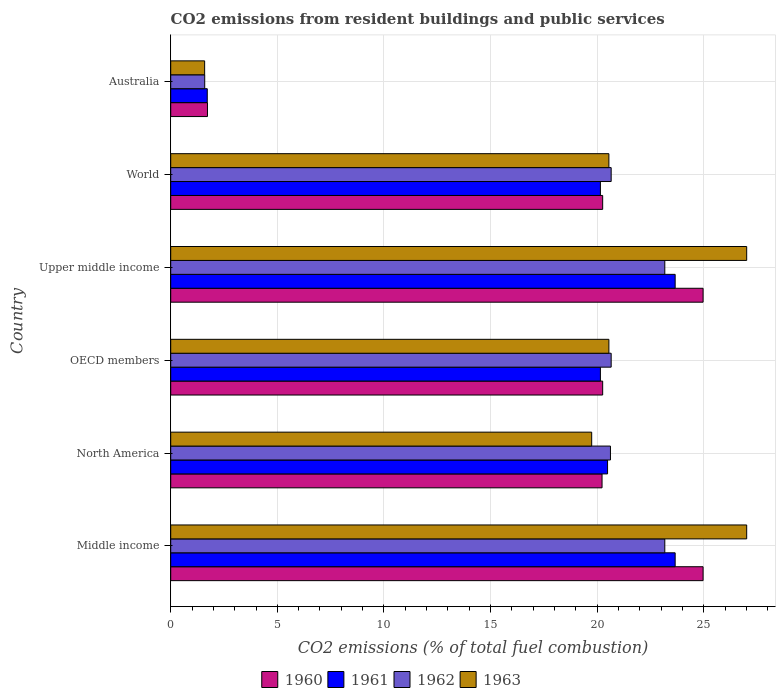How many different coloured bars are there?
Your response must be concise. 4. How many groups of bars are there?
Provide a succinct answer. 6. How many bars are there on the 6th tick from the top?
Your answer should be very brief. 4. How many bars are there on the 4th tick from the bottom?
Make the answer very short. 4. What is the label of the 6th group of bars from the top?
Ensure brevity in your answer.  Middle income. What is the total CO2 emitted in 1961 in Australia?
Your response must be concise. 1.71. Across all countries, what is the maximum total CO2 emitted in 1961?
Give a very brief answer. 23.66. Across all countries, what is the minimum total CO2 emitted in 1963?
Your response must be concise. 1.59. In which country was the total CO2 emitted in 1961 maximum?
Ensure brevity in your answer.  Middle income. In which country was the total CO2 emitted in 1963 minimum?
Offer a very short reply. Australia. What is the total total CO2 emitted in 1961 in the graph?
Provide a succinct answer. 109.83. What is the difference between the total CO2 emitted in 1963 in Australia and that in OECD members?
Ensure brevity in your answer.  -18.96. What is the difference between the total CO2 emitted in 1960 in North America and the total CO2 emitted in 1961 in World?
Keep it short and to the point. 0.08. What is the average total CO2 emitted in 1960 per country?
Make the answer very short. 18.74. What is the difference between the total CO2 emitted in 1963 and total CO2 emitted in 1961 in Middle income?
Provide a short and direct response. 3.36. What is the ratio of the total CO2 emitted in 1962 in Upper middle income to that in World?
Keep it short and to the point. 1.12. What is the difference between the highest and the second highest total CO2 emitted in 1962?
Offer a terse response. 0. What is the difference between the highest and the lowest total CO2 emitted in 1963?
Make the answer very short. 25.42. In how many countries, is the total CO2 emitted in 1961 greater than the average total CO2 emitted in 1961 taken over all countries?
Give a very brief answer. 5. Is it the case that in every country, the sum of the total CO2 emitted in 1962 and total CO2 emitted in 1961 is greater than the sum of total CO2 emitted in 1960 and total CO2 emitted in 1963?
Provide a succinct answer. No. What does the 1st bar from the top in Middle income represents?
Ensure brevity in your answer.  1963. What does the 2nd bar from the bottom in OECD members represents?
Your answer should be very brief. 1961. Are all the bars in the graph horizontal?
Your answer should be very brief. Yes. Where does the legend appear in the graph?
Give a very brief answer. Bottom center. How are the legend labels stacked?
Your answer should be very brief. Horizontal. What is the title of the graph?
Offer a terse response. CO2 emissions from resident buildings and public services. What is the label or title of the X-axis?
Keep it short and to the point. CO2 emissions (% of total fuel combustion). What is the CO2 emissions (% of total fuel combustion) in 1960 in Middle income?
Your answer should be very brief. 24.97. What is the CO2 emissions (% of total fuel combustion) of 1961 in Middle income?
Your response must be concise. 23.66. What is the CO2 emissions (% of total fuel combustion) in 1962 in Middle income?
Offer a terse response. 23.17. What is the CO2 emissions (% of total fuel combustion) of 1963 in Middle income?
Your answer should be very brief. 27.01. What is the CO2 emissions (% of total fuel combustion) in 1960 in North America?
Give a very brief answer. 20.23. What is the CO2 emissions (% of total fuel combustion) of 1961 in North America?
Your answer should be very brief. 20.49. What is the CO2 emissions (% of total fuel combustion) of 1962 in North America?
Offer a very short reply. 20.62. What is the CO2 emissions (% of total fuel combustion) of 1963 in North America?
Your response must be concise. 19.74. What is the CO2 emissions (% of total fuel combustion) in 1960 in OECD members?
Ensure brevity in your answer.  20.26. What is the CO2 emissions (% of total fuel combustion) in 1961 in OECD members?
Provide a succinct answer. 20.15. What is the CO2 emissions (% of total fuel combustion) of 1962 in OECD members?
Offer a very short reply. 20.66. What is the CO2 emissions (% of total fuel combustion) in 1963 in OECD members?
Make the answer very short. 20.55. What is the CO2 emissions (% of total fuel combustion) of 1960 in Upper middle income?
Provide a short and direct response. 24.97. What is the CO2 emissions (% of total fuel combustion) of 1961 in Upper middle income?
Ensure brevity in your answer.  23.66. What is the CO2 emissions (% of total fuel combustion) of 1962 in Upper middle income?
Offer a very short reply. 23.17. What is the CO2 emissions (% of total fuel combustion) of 1963 in Upper middle income?
Your response must be concise. 27.01. What is the CO2 emissions (% of total fuel combustion) in 1960 in World?
Give a very brief answer. 20.26. What is the CO2 emissions (% of total fuel combustion) of 1961 in World?
Your response must be concise. 20.15. What is the CO2 emissions (% of total fuel combustion) of 1962 in World?
Your answer should be very brief. 20.66. What is the CO2 emissions (% of total fuel combustion) of 1963 in World?
Provide a succinct answer. 20.55. What is the CO2 emissions (% of total fuel combustion) in 1960 in Australia?
Give a very brief answer. 1.72. What is the CO2 emissions (% of total fuel combustion) in 1961 in Australia?
Provide a short and direct response. 1.71. What is the CO2 emissions (% of total fuel combustion) in 1962 in Australia?
Keep it short and to the point. 1.59. What is the CO2 emissions (% of total fuel combustion) in 1963 in Australia?
Make the answer very short. 1.59. Across all countries, what is the maximum CO2 emissions (% of total fuel combustion) of 1960?
Provide a short and direct response. 24.97. Across all countries, what is the maximum CO2 emissions (% of total fuel combustion) in 1961?
Provide a succinct answer. 23.66. Across all countries, what is the maximum CO2 emissions (% of total fuel combustion) of 1962?
Your answer should be compact. 23.17. Across all countries, what is the maximum CO2 emissions (% of total fuel combustion) in 1963?
Provide a short and direct response. 27.01. Across all countries, what is the minimum CO2 emissions (% of total fuel combustion) in 1960?
Provide a short and direct response. 1.72. Across all countries, what is the minimum CO2 emissions (% of total fuel combustion) in 1961?
Keep it short and to the point. 1.71. Across all countries, what is the minimum CO2 emissions (% of total fuel combustion) of 1962?
Give a very brief answer. 1.59. Across all countries, what is the minimum CO2 emissions (% of total fuel combustion) of 1963?
Your answer should be compact. 1.59. What is the total CO2 emissions (% of total fuel combustion) in 1960 in the graph?
Give a very brief answer. 112.41. What is the total CO2 emissions (% of total fuel combustion) of 1961 in the graph?
Ensure brevity in your answer.  109.83. What is the total CO2 emissions (% of total fuel combustion) in 1962 in the graph?
Offer a very short reply. 109.88. What is the total CO2 emissions (% of total fuel combustion) of 1963 in the graph?
Give a very brief answer. 116.47. What is the difference between the CO2 emissions (% of total fuel combustion) of 1960 in Middle income and that in North America?
Your answer should be compact. 4.74. What is the difference between the CO2 emissions (% of total fuel combustion) in 1961 in Middle income and that in North America?
Your response must be concise. 3.17. What is the difference between the CO2 emissions (% of total fuel combustion) of 1962 in Middle income and that in North America?
Offer a very short reply. 2.55. What is the difference between the CO2 emissions (% of total fuel combustion) of 1963 in Middle income and that in North America?
Offer a terse response. 7.27. What is the difference between the CO2 emissions (% of total fuel combustion) in 1960 in Middle income and that in OECD members?
Make the answer very short. 4.71. What is the difference between the CO2 emissions (% of total fuel combustion) of 1961 in Middle income and that in OECD members?
Ensure brevity in your answer.  3.51. What is the difference between the CO2 emissions (% of total fuel combustion) of 1962 in Middle income and that in OECD members?
Ensure brevity in your answer.  2.52. What is the difference between the CO2 emissions (% of total fuel combustion) of 1963 in Middle income and that in OECD members?
Provide a succinct answer. 6.46. What is the difference between the CO2 emissions (% of total fuel combustion) in 1962 in Middle income and that in Upper middle income?
Provide a short and direct response. 0. What is the difference between the CO2 emissions (% of total fuel combustion) in 1960 in Middle income and that in World?
Keep it short and to the point. 4.71. What is the difference between the CO2 emissions (% of total fuel combustion) of 1961 in Middle income and that in World?
Ensure brevity in your answer.  3.51. What is the difference between the CO2 emissions (% of total fuel combustion) in 1962 in Middle income and that in World?
Offer a terse response. 2.52. What is the difference between the CO2 emissions (% of total fuel combustion) in 1963 in Middle income and that in World?
Provide a short and direct response. 6.46. What is the difference between the CO2 emissions (% of total fuel combustion) in 1960 in Middle income and that in Australia?
Offer a very short reply. 23.25. What is the difference between the CO2 emissions (% of total fuel combustion) in 1961 in Middle income and that in Australia?
Provide a succinct answer. 21.95. What is the difference between the CO2 emissions (% of total fuel combustion) in 1962 in Middle income and that in Australia?
Provide a short and direct response. 21.58. What is the difference between the CO2 emissions (% of total fuel combustion) of 1963 in Middle income and that in Australia?
Keep it short and to the point. 25.42. What is the difference between the CO2 emissions (% of total fuel combustion) in 1960 in North America and that in OECD members?
Offer a very short reply. -0.03. What is the difference between the CO2 emissions (% of total fuel combustion) of 1961 in North America and that in OECD members?
Provide a succinct answer. 0.34. What is the difference between the CO2 emissions (% of total fuel combustion) in 1962 in North America and that in OECD members?
Offer a terse response. -0.03. What is the difference between the CO2 emissions (% of total fuel combustion) of 1963 in North America and that in OECD members?
Ensure brevity in your answer.  -0.81. What is the difference between the CO2 emissions (% of total fuel combustion) in 1960 in North America and that in Upper middle income?
Offer a terse response. -4.74. What is the difference between the CO2 emissions (% of total fuel combustion) in 1961 in North America and that in Upper middle income?
Provide a short and direct response. -3.17. What is the difference between the CO2 emissions (% of total fuel combustion) in 1962 in North America and that in Upper middle income?
Ensure brevity in your answer.  -2.55. What is the difference between the CO2 emissions (% of total fuel combustion) in 1963 in North America and that in Upper middle income?
Provide a short and direct response. -7.27. What is the difference between the CO2 emissions (% of total fuel combustion) of 1960 in North America and that in World?
Ensure brevity in your answer.  -0.03. What is the difference between the CO2 emissions (% of total fuel combustion) of 1961 in North America and that in World?
Your answer should be very brief. 0.34. What is the difference between the CO2 emissions (% of total fuel combustion) in 1962 in North America and that in World?
Offer a very short reply. -0.03. What is the difference between the CO2 emissions (% of total fuel combustion) of 1963 in North America and that in World?
Keep it short and to the point. -0.81. What is the difference between the CO2 emissions (% of total fuel combustion) of 1960 in North America and that in Australia?
Give a very brief answer. 18.51. What is the difference between the CO2 emissions (% of total fuel combustion) of 1961 in North America and that in Australia?
Make the answer very short. 18.77. What is the difference between the CO2 emissions (% of total fuel combustion) in 1962 in North America and that in Australia?
Your response must be concise. 19.03. What is the difference between the CO2 emissions (% of total fuel combustion) in 1963 in North America and that in Australia?
Your answer should be very brief. 18.15. What is the difference between the CO2 emissions (% of total fuel combustion) of 1960 in OECD members and that in Upper middle income?
Provide a short and direct response. -4.71. What is the difference between the CO2 emissions (% of total fuel combustion) in 1961 in OECD members and that in Upper middle income?
Ensure brevity in your answer.  -3.51. What is the difference between the CO2 emissions (% of total fuel combustion) of 1962 in OECD members and that in Upper middle income?
Your answer should be very brief. -2.52. What is the difference between the CO2 emissions (% of total fuel combustion) of 1963 in OECD members and that in Upper middle income?
Your response must be concise. -6.46. What is the difference between the CO2 emissions (% of total fuel combustion) of 1961 in OECD members and that in World?
Provide a short and direct response. 0. What is the difference between the CO2 emissions (% of total fuel combustion) in 1962 in OECD members and that in World?
Your answer should be compact. 0. What is the difference between the CO2 emissions (% of total fuel combustion) of 1963 in OECD members and that in World?
Provide a succinct answer. 0. What is the difference between the CO2 emissions (% of total fuel combustion) of 1960 in OECD members and that in Australia?
Your answer should be compact. 18.54. What is the difference between the CO2 emissions (% of total fuel combustion) of 1961 in OECD members and that in Australia?
Ensure brevity in your answer.  18.44. What is the difference between the CO2 emissions (% of total fuel combustion) of 1962 in OECD members and that in Australia?
Provide a succinct answer. 19.06. What is the difference between the CO2 emissions (% of total fuel combustion) of 1963 in OECD members and that in Australia?
Your response must be concise. 18.96. What is the difference between the CO2 emissions (% of total fuel combustion) of 1960 in Upper middle income and that in World?
Ensure brevity in your answer.  4.71. What is the difference between the CO2 emissions (% of total fuel combustion) in 1961 in Upper middle income and that in World?
Give a very brief answer. 3.51. What is the difference between the CO2 emissions (% of total fuel combustion) of 1962 in Upper middle income and that in World?
Your answer should be very brief. 2.52. What is the difference between the CO2 emissions (% of total fuel combustion) in 1963 in Upper middle income and that in World?
Give a very brief answer. 6.46. What is the difference between the CO2 emissions (% of total fuel combustion) of 1960 in Upper middle income and that in Australia?
Keep it short and to the point. 23.25. What is the difference between the CO2 emissions (% of total fuel combustion) of 1961 in Upper middle income and that in Australia?
Offer a terse response. 21.95. What is the difference between the CO2 emissions (% of total fuel combustion) in 1962 in Upper middle income and that in Australia?
Provide a short and direct response. 21.58. What is the difference between the CO2 emissions (% of total fuel combustion) in 1963 in Upper middle income and that in Australia?
Your response must be concise. 25.42. What is the difference between the CO2 emissions (% of total fuel combustion) of 1960 in World and that in Australia?
Offer a very short reply. 18.54. What is the difference between the CO2 emissions (% of total fuel combustion) in 1961 in World and that in Australia?
Your answer should be compact. 18.44. What is the difference between the CO2 emissions (% of total fuel combustion) in 1962 in World and that in Australia?
Your response must be concise. 19.06. What is the difference between the CO2 emissions (% of total fuel combustion) of 1963 in World and that in Australia?
Your answer should be compact. 18.96. What is the difference between the CO2 emissions (% of total fuel combustion) of 1960 in Middle income and the CO2 emissions (% of total fuel combustion) of 1961 in North America?
Provide a short and direct response. 4.48. What is the difference between the CO2 emissions (% of total fuel combustion) of 1960 in Middle income and the CO2 emissions (% of total fuel combustion) of 1962 in North America?
Keep it short and to the point. 4.35. What is the difference between the CO2 emissions (% of total fuel combustion) of 1960 in Middle income and the CO2 emissions (% of total fuel combustion) of 1963 in North America?
Offer a terse response. 5.22. What is the difference between the CO2 emissions (% of total fuel combustion) in 1961 in Middle income and the CO2 emissions (% of total fuel combustion) in 1962 in North America?
Your answer should be very brief. 3.04. What is the difference between the CO2 emissions (% of total fuel combustion) in 1961 in Middle income and the CO2 emissions (% of total fuel combustion) in 1963 in North America?
Ensure brevity in your answer.  3.92. What is the difference between the CO2 emissions (% of total fuel combustion) in 1962 in Middle income and the CO2 emissions (% of total fuel combustion) in 1963 in North America?
Provide a succinct answer. 3.43. What is the difference between the CO2 emissions (% of total fuel combustion) of 1960 in Middle income and the CO2 emissions (% of total fuel combustion) of 1961 in OECD members?
Keep it short and to the point. 4.82. What is the difference between the CO2 emissions (% of total fuel combustion) of 1960 in Middle income and the CO2 emissions (% of total fuel combustion) of 1962 in OECD members?
Your response must be concise. 4.31. What is the difference between the CO2 emissions (% of total fuel combustion) of 1960 in Middle income and the CO2 emissions (% of total fuel combustion) of 1963 in OECD members?
Provide a short and direct response. 4.42. What is the difference between the CO2 emissions (% of total fuel combustion) in 1961 in Middle income and the CO2 emissions (% of total fuel combustion) in 1962 in OECD members?
Keep it short and to the point. 3. What is the difference between the CO2 emissions (% of total fuel combustion) in 1961 in Middle income and the CO2 emissions (% of total fuel combustion) in 1963 in OECD members?
Your answer should be very brief. 3.11. What is the difference between the CO2 emissions (% of total fuel combustion) in 1962 in Middle income and the CO2 emissions (% of total fuel combustion) in 1963 in OECD members?
Make the answer very short. 2.62. What is the difference between the CO2 emissions (% of total fuel combustion) in 1960 in Middle income and the CO2 emissions (% of total fuel combustion) in 1961 in Upper middle income?
Your response must be concise. 1.31. What is the difference between the CO2 emissions (% of total fuel combustion) in 1960 in Middle income and the CO2 emissions (% of total fuel combustion) in 1962 in Upper middle income?
Provide a short and direct response. 1.8. What is the difference between the CO2 emissions (% of total fuel combustion) in 1960 in Middle income and the CO2 emissions (% of total fuel combustion) in 1963 in Upper middle income?
Make the answer very short. -2.05. What is the difference between the CO2 emissions (% of total fuel combustion) in 1961 in Middle income and the CO2 emissions (% of total fuel combustion) in 1962 in Upper middle income?
Your response must be concise. 0.49. What is the difference between the CO2 emissions (% of total fuel combustion) of 1961 in Middle income and the CO2 emissions (% of total fuel combustion) of 1963 in Upper middle income?
Provide a short and direct response. -3.35. What is the difference between the CO2 emissions (% of total fuel combustion) in 1962 in Middle income and the CO2 emissions (% of total fuel combustion) in 1963 in Upper middle income?
Give a very brief answer. -3.84. What is the difference between the CO2 emissions (% of total fuel combustion) in 1960 in Middle income and the CO2 emissions (% of total fuel combustion) in 1961 in World?
Give a very brief answer. 4.82. What is the difference between the CO2 emissions (% of total fuel combustion) of 1960 in Middle income and the CO2 emissions (% of total fuel combustion) of 1962 in World?
Make the answer very short. 4.31. What is the difference between the CO2 emissions (% of total fuel combustion) of 1960 in Middle income and the CO2 emissions (% of total fuel combustion) of 1963 in World?
Provide a short and direct response. 4.42. What is the difference between the CO2 emissions (% of total fuel combustion) of 1961 in Middle income and the CO2 emissions (% of total fuel combustion) of 1962 in World?
Offer a terse response. 3. What is the difference between the CO2 emissions (% of total fuel combustion) of 1961 in Middle income and the CO2 emissions (% of total fuel combustion) of 1963 in World?
Offer a very short reply. 3.11. What is the difference between the CO2 emissions (% of total fuel combustion) in 1962 in Middle income and the CO2 emissions (% of total fuel combustion) in 1963 in World?
Provide a succinct answer. 2.62. What is the difference between the CO2 emissions (% of total fuel combustion) of 1960 in Middle income and the CO2 emissions (% of total fuel combustion) of 1961 in Australia?
Make the answer very short. 23.26. What is the difference between the CO2 emissions (% of total fuel combustion) of 1960 in Middle income and the CO2 emissions (% of total fuel combustion) of 1962 in Australia?
Keep it short and to the point. 23.38. What is the difference between the CO2 emissions (% of total fuel combustion) of 1960 in Middle income and the CO2 emissions (% of total fuel combustion) of 1963 in Australia?
Your answer should be compact. 23.38. What is the difference between the CO2 emissions (% of total fuel combustion) in 1961 in Middle income and the CO2 emissions (% of total fuel combustion) in 1962 in Australia?
Ensure brevity in your answer.  22.07. What is the difference between the CO2 emissions (% of total fuel combustion) of 1961 in Middle income and the CO2 emissions (% of total fuel combustion) of 1963 in Australia?
Offer a very short reply. 22.07. What is the difference between the CO2 emissions (% of total fuel combustion) of 1962 in Middle income and the CO2 emissions (% of total fuel combustion) of 1963 in Australia?
Offer a terse response. 21.58. What is the difference between the CO2 emissions (% of total fuel combustion) of 1960 in North America and the CO2 emissions (% of total fuel combustion) of 1961 in OECD members?
Give a very brief answer. 0.08. What is the difference between the CO2 emissions (% of total fuel combustion) in 1960 in North America and the CO2 emissions (% of total fuel combustion) in 1962 in OECD members?
Ensure brevity in your answer.  -0.43. What is the difference between the CO2 emissions (% of total fuel combustion) in 1960 in North America and the CO2 emissions (% of total fuel combustion) in 1963 in OECD members?
Offer a very short reply. -0.32. What is the difference between the CO2 emissions (% of total fuel combustion) in 1961 in North America and the CO2 emissions (% of total fuel combustion) in 1962 in OECD members?
Your answer should be very brief. -0.17. What is the difference between the CO2 emissions (% of total fuel combustion) in 1961 in North America and the CO2 emissions (% of total fuel combustion) in 1963 in OECD members?
Offer a very short reply. -0.06. What is the difference between the CO2 emissions (% of total fuel combustion) in 1962 in North America and the CO2 emissions (% of total fuel combustion) in 1963 in OECD members?
Your answer should be compact. 0.07. What is the difference between the CO2 emissions (% of total fuel combustion) of 1960 in North America and the CO2 emissions (% of total fuel combustion) of 1961 in Upper middle income?
Provide a short and direct response. -3.43. What is the difference between the CO2 emissions (% of total fuel combustion) of 1960 in North America and the CO2 emissions (% of total fuel combustion) of 1962 in Upper middle income?
Your answer should be very brief. -2.94. What is the difference between the CO2 emissions (% of total fuel combustion) in 1960 in North America and the CO2 emissions (% of total fuel combustion) in 1963 in Upper middle income?
Provide a succinct answer. -6.78. What is the difference between the CO2 emissions (% of total fuel combustion) of 1961 in North America and the CO2 emissions (% of total fuel combustion) of 1962 in Upper middle income?
Your answer should be very brief. -2.68. What is the difference between the CO2 emissions (% of total fuel combustion) in 1961 in North America and the CO2 emissions (% of total fuel combustion) in 1963 in Upper middle income?
Offer a very short reply. -6.53. What is the difference between the CO2 emissions (% of total fuel combustion) in 1962 in North America and the CO2 emissions (% of total fuel combustion) in 1963 in Upper middle income?
Keep it short and to the point. -6.39. What is the difference between the CO2 emissions (% of total fuel combustion) in 1960 in North America and the CO2 emissions (% of total fuel combustion) in 1961 in World?
Provide a succinct answer. 0.08. What is the difference between the CO2 emissions (% of total fuel combustion) of 1960 in North America and the CO2 emissions (% of total fuel combustion) of 1962 in World?
Your answer should be very brief. -0.43. What is the difference between the CO2 emissions (% of total fuel combustion) of 1960 in North America and the CO2 emissions (% of total fuel combustion) of 1963 in World?
Your response must be concise. -0.32. What is the difference between the CO2 emissions (% of total fuel combustion) in 1961 in North America and the CO2 emissions (% of total fuel combustion) in 1962 in World?
Provide a short and direct response. -0.17. What is the difference between the CO2 emissions (% of total fuel combustion) in 1961 in North America and the CO2 emissions (% of total fuel combustion) in 1963 in World?
Offer a terse response. -0.06. What is the difference between the CO2 emissions (% of total fuel combustion) in 1962 in North America and the CO2 emissions (% of total fuel combustion) in 1963 in World?
Offer a terse response. 0.07. What is the difference between the CO2 emissions (% of total fuel combustion) of 1960 in North America and the CO2 emissions (% of total fuel combustion) of 1961 in Australia?
Your response must be concise. 18.52. What is the difference between the CO2 emissions (% of total fuel combustion) in 1960 in North America and the CO2 emissions (% of total fuel combustion) in 1962 in Australia?
Provide a short and direct response. 18.64. What is the difference between the CO2 emissions (% of total fuel combustion) in 1960 in North America and the CO2 emissions (% of total fuel combustion) in 1963 in Australia?
Make the answer very short. 18.64. What is the difference between the CO2 emissions (% of total fuel combustion) of 1961 in North America and the CO2 emissions (% of total fuel combustion) of 1962 in Australia?
Offer a very short reply. 18.89. What is the difference between the CO2 emissions (% of total fuel combustion) of 1961 in North America and the CO2 emissions (% of total fuel combustion) of 1963 in Australia?
Provide a succinct answer. 18.9. What is the difference between the CO2 emissions (% of total fuel combustion) in 1962 in North America and the CO2 emissions (% of total fuel combustion) in 1963 in Australia?
Offer a terse response. 19.03. What is the difference between the CO2 emissions (% of total fuel combustion) of 1960 in OECD members and the CO2 emissions (% of total fuel combustion) of 1961 in Upper middle income?
Provide a succinct answer. -3.4. What is the difference between the CO2 emissions (% of total fuel combustion) of 1960 in OECD members and the CO2 emissions (% of total fuel combustion) of 1962 in Upper middle income?
Give a very brief answer. -2.91. What is the difference between the CO2 emissions (% of total fuel combustion) of 1960 in OECD members and the CO2 emissions (% of total fuel combustion) of 1963 in Upper middle income?
Make the answer very short. -6.75. What is the difference between the CO2 emissions (% of total fuel combustion) of 1961 in OECD members and the CO2 emissions (% of total fuel combustion) of 1962 in Upper middle income?
Your answer should be very brief. -3.02. What is the difference between the CO2 emissions (% of total fuel combustion) of 1961 in OECD members and the CO2 emissions (% of total fuel combustion) of 1963 in Upper middle income?
Keep it short and to the point. -6.86. What is the difference between the CO2 emissions (% of total fuel combustion) in 1962 in OECD members and the CO2 emissions (% of total fuel combustion) in 1963 in Upper middle income?
Provide a short and direct response. -6.36. What is the difference between the CO2 emissions (% of total fuel combustion) of 1960 in OECD members and the CO2 emissions (% of total fuel combustion) of 1961 in World?
Ensure brevity in your answer.  0.11. What is the difference between the CO2 emissions (% of total fuel combustion) in 1960 in OECD members and the CO2 emissions (% of total fuel combustion) in 1962 in World?
Make the answer very short. -0.4. What is the difference between the CO2 emissions (% of total fuel combustion) in 1960 in OECD members and the CO2 emissions (% of total fuel combustion) in 1963 in World?
Your answer should be compact. -0.29. What is the difference between the CO2 emissions (% of total fuel combustion) in 1961 in OECD members and the CO2 emissions (% of total fuel combustion) in 1962 in World?
Ensure brevity in your answer.  -0.5. What is the difference between the CO2 emissions (% of total fuel combustion) of 1961 in OECD members and the CO2 emissions (% of total fuel combustion) of 1963 in World?
Offer a terse response. -0.4. What is the difference between the CO2 emissions (% of total fuel combustion) of 1962 in OECD members and the CO2 emissions (% of total fuel combustion) of 1963 in World?
Keep it short and to the point. 0.11. What is the difference between the CO2 emissions (% of total fuel combustion) of 1960 in OECD members and the CO2 emissions (% of total fuel combustion) of 1961 in Australia?
Give a very brief answer. 18.55. What is the difference between the CO2 emissions (% of total fuel combustion) in 1960 in OECD members and the CO2 emissions (% of total fuel combustion) in 1962 in Australia?
Give a very brief answer. 18.67. What is the difference between the CO2 emissions (% of total fuel combustion) in 1960 in OECD members and the CO2 emissions (% of total fuel combustion) in 1963 in Australia?
Give a very brief answer. 18.67. What is the difference between the CO2 emissions (% of total fuel combustion) of 1961 in OECD members and the CO2 emissions (% of total fuel combustion) of 1962 in Australia?
Offer a terse response. 18.56. What is the difference between the CO2 emissions (% of total fuel combustion) in 1961 in OECD members and the CO2 emissions (% of total fuel combustion) in 1963 in Australia?
Your response must be concise. 18.56. What is the difference between the CO2 emissions (% of total fuel combustion) of 1962 in OECD members and the CO2 emissions (% of total fuel combustion) of 1963 in Australia?
Keep it short and to the point. 19.07. What is the difference between the CO2 emissions (% of total fuel combustion) of 1960 in Upper middle income and the CO2 emissions (% of total fuel combustion) of 1961 in World?
Keep it short and to the point. 4.82. What is the difference between the CO2 emissions (% of total fuel combustion) in 1960 in Upper middle income and the CO2 emissions (% of total fuel combustion) in 1962 in World?
Your answer should be compact. 4.31. What is the difference between the CO2 emissions (% of total fuel combustion) in 1960 in Upper middle income and the CO2 emissions (% of total fuel combustion) in 1963 in World?
Ensure brevity in your answer.  4.42. What is the difference between the CO2 emissions (% of total fuel combustion) in 1961 in Upper middle income and the CO2 emissions (% of total fuel combustion) in 1962 in World?
Provide a succinct answer. 3. What is the difference between the CO2 emissions (% of total fuel combustion) of 1961 in Upper middle income and the CO2 emissions (% of total fuel combustion) of 1963 in World?
Give a very brief answer. 3.11. What is the difference between the CO2 emissions (% of total fuel combustion) in 1962 in Upper middle income and the CO2 emissions (% of total fuel combustion) in 1963 in World?
Make the answer very short. 2.62. What is the difference between the CO2 emissions (% of total fuel combustion) in 1960 in Upper middle income and the CO2 emissions (% of total fuel combustion) in 1961 in Australia?
Ensure brevity in your answer.  23.26. What is the difference between the CO2 emissions (% of total fuel combustion) in 1960 in Upper middle income and the CO2 emissions (% of total fuel combustion) in 1962 in Australia?
Your answer should be very brief. 23.38. What is the difference between the CO2 emissions (% of total fuel combustion) in 1960 in Upper middle income and the CO2 emissions (% of total fuel combustion) in 1963 in Australia?
Offer a very short reply. 23.38. What is the difference between the CO2 emissions (% of total fuel combustion) of 1961 in Upper middle income and the CO2 emissions (% of total fuel combustion) of 1962 in Australia?
Make the answer very short. 22.07. What is the difference between the CO2 emissions (% of total fuel combustion) of 1961 in Upper middle income and the CO2 emissions (% of total fuel combustion) of 1963 in Australia?
Your answer should be very brief. 22.07. What is the difference between the CO2 emissions (% of total fuel combustion) in 1962 in Upper middle income and the CO2 emissions (% of total fuel combustion) in 1963 in Australia?
Give a very brief answer. 21.58. What is the difference between the CO2 emissions (% of total fuel combustion) of 1960 in World and the CO2 emissions (% of total fuel combustion) of 1961 in Australia?
Your answer should be very brief. 18.55. What is the difference between the CO2 emissions (% of total fuel combustion) of 1960 in World and the CO2 emissions (% of total fuel combustion) of 1962 in Australia?
Your answer should be compact. 18.67. What is the difference between the CO2 emissions (% of total fuel combustion) in 1960 in World and the CO2 emissions (% of total fuel combustion) in 1963 in Australia?
Provide a short and direct response. 18.67. What is the difference between the CO2 emissions (% of total fuel combustion) of 1961 in World and the CO2 emissions (% of total fuel combustion) of 1962 in Australia?
Your answer should be compact. 18.56. What is the difference between the CO2 emissions (% of total fuel combustion) of 1961 in World and the CO2 emissions (% of total fuel combustion) of 1963 in Australia?
Keep it short and to the point. 18.56. What is the difference between the CO2 emissions (% of total fuel combustion) in 1962 in World and the CO2 emissions (% of total fuel combustion) in 1963 in Australia?
Give a very brief answer. 19.07. What is the average CO2 emissions (% of total fuel combustion) in 1960 per country?
Give a very brief answer. 18.74. What is the average CO2 emissions (% of total fuel combustion) of 1961 per country?
Make the answer very short. 18.3. What is the average CO2 emissions (% of total fuel combustion) of 1962 per country?
Your answer should be compact. 18.31. What is the average CO2 emissions (% of total fuel combustion) of 1963 per country?
Offer a very short reply. 19.41. What is the difference between the CO2 emissions (% of total fuel combustion) in 1960 and CO2 emissions (% of total fuel combustion) in 1961 in Middle income?
Your answer should be very brief. 1.31. What is the difference between the CO2 emissions (% of total fuel combustion) in 1960 and CO2 emissions (% of total fuel combustion) in 1962 in Middle income?
Give a very brief answer. 1.8. What is the difference between the CO2 emissions (% of total fuel combustion) in 1960 and CO2 emissions (% of total fuel combustion) in 1963 in Middle income?
Ensure brevity in your answer.  -2.05. What is the difference between the CO2 emissions (% of total fuel combustion) in 1961 and CO2 emissions (% of total fuel combustion) in 1962 in Middle income?
Provide a short and direct response. 0.49. What is the difference between the CO2 emissions (% of total fuel combustion) of 1961 and CO2 emissions (% of total fuel combustion) of 1963 in Middle income?
Your answer should be very brief. -3.35. What is the difference between the CO2 emissions (% of total fuel combustion) of 1962 and CO2 emissions (% of total fuel combustion) of 1963 in Middle income?
Your response must be concise. -3.84. What is the difference between the CO2 emissions (% of total fuel combustion) of 1960 and CO2 emissions (% of total fuel combustion) of 1961 in North America?
Your answer should be very brief. -0.26. What is the difference between the CO2 emissions (% of total fuel combustion) in 1960 and CO2 emissions (% of total fuel combustion) in 1962 in North America?
Offer a very short reply. -0.39. What is the difference between the CO2 emissions (% of total fuel combustion) in 1960 and CO2 emissions (% of total fuel combustion) in 1963 in North America?
Keep it short and to the point. 0.49. What is the difference between the CO2 emissions (% of total fuel combustion) of 1961 and CO2 emissions (% of total fuel combustion) of 1962 in North America?
Provide a succinct answer. -0.14. What is the difference between the CO2 emissions (% of total fuel combustion) of 1961 and CO2 emissions (% of total fuel combustion) of 1963 in North America?
Provide a short and direct response. 0.74. What is the difference between the CO2 emissions (% of total fuel combustion) in 1962 and CO2 emissions (% of total fuel combustion) in 1963 in North America?
Your answer should be very brief. 0.88. What is the difference between the CO2 emissions (% of total fuel combustion) in 1960 and CO2 emissions (% of total fuel combustion) in 1961 in OECD members?
Offer a very short reply. 0.11. What is the difference between the CO2 emissions (% of total fuel combustion) in 1960 and CO2 emissions (% of total fuel combustion) in 1962 in OECD members?
Offer a very short reply. -0.4. What is the difference between the CO2 emissions (% of total fuel combustion) in 1960 and CO2 emissions (% of total fuel combustion) in 1963 in OECD members?
Your answer should be compact. -0.29. What is the difference between the CO2 emissions (% of total fuel combustion) of 1961 and CO2 emissions (% of total fuel combustion) of 1962 in OECD members?
Give a very brief answer. -0.5. What is the difference between the CO2 emissions (% of total fuel combustion) in 1961 and CO2 emissions (% of total fuel combustion) in 1963 in OECD members?
Give a very brief answer. -0.4. What is the difference between the CO2 emissions (% of total fuel combustion) in 1962 and CO2 emissions (% of total fuel combustion) in 1963 in OECD members?
Your answer should be very brief. 0.11. What is the difference between the CO2 emissions (% of total fuel combustion) of 1960 and CO2 emissions (% of total fuel combustion) of 1961 in Upper middle income?
Keep it short and to the point. 1.31. What is the difference between the CO2 emissions (% of total fuel combustion) in 1960 and CO2 emissions (% of total fuel combustion) in 1962 in Upper middle income?
Your response must be concise. 1.8. What is the difference between the CO2 emissions (% of total fuel combustion) in 1960 and CO2 emissions (% of total fuel combustion) in 1963 in Upper middle income?
Your answer should be very brief. -2.05. What is the difference between the CO2 emissions (% of total fuel combustion) in 1961 and CO2 emissions (% of total fuel combustion) in 1962 in Upper middle income?
Offer a terse response. 0.49. What is the difference between the CO2 emissions (% of total fuel combustion) of 1961 and CO2 emissions (% of total fuel combustion) of 1963 in Upper middle income?
Offer a terse response. -3.35. What is the difference between the CO2 emissions (% of total fuel combustion) in 1962 and CO2 emissions (% of total fuel combustion) in 1963 in Upper middle income?
Keep it short and to the point. -3.84. What is the difference between the CO2 emissions (% of total fuel combustion) in 1960 and CO2 emissions (% of total fuel combustion) in 1961 in World?
Make the answer very short. 0.11. What is the difference between the CO2 emissions (% of total fuel combustion) of 1960 and CO2 emissions (% of total fuel combustion) of 1962 in World?
Provide a succinct answer. -0.4. What is the difference between the CO2 emissions (% of total fuel combustion) in 1960 and CO2 emissions (% of total fuel combustion) in 1963 in World?
Offer a terse response. -0.29. What is the difference between the CO2 emissions (% of total fuel combustion) in 1961 and CO2 emissions (% of total fuel combustion) in 1962 in World?
Your response must be concise. -0.5. What is the difference between the CO2 emissions (% of total fuel combustion) of 1961 and CO2 emissions (% of total fuel combustion) of 1963 in World?
Make the answer very short. -0.4. What is the difference between the CO2 emissions (% of total fuel combustion) in 1962 and CO2 emissions (% of total fuel combustion) in 1963 in World?
Keep it short and to the point. 0.11. What is the difference between the CO2 emissions (% of total fuel combustion) in 1960 and CO2 emissions (% of total fuel combustion) in 1961 in Australia?
Make the answer very short. 0.01. What is the difference between the CO2 emissions (% of total fuel combustion) of 1960 and CO2 emissions (% of total fuel combustion) of 1962 in Australia?
Your answer should be compact. 0.13. What is the difference between the CO2 emissions (% of total fuel combustion) in 1960 and CO2 emissions (% of total fuel combustion) in 1963 in Australia?
Offer a terse response. 0.13. What is the difference between the CO2 emissions (% of total fuel combustion) of 1961 and CO2 emissions (% of total fuel combustion) of 1962 in Australia?
Make the answer very short. 0.12. What is the difference between the CO2 emissions (% of total fuel combustion) of 1961 and CO2 emissions (% of total fuel combustion) of 1963 in Australia?
Your answer should be very brief. 0.12. What is the difference between the CO2 emissions (% of total fuel combustion) of 1962 and CO2 emissions (% of total fuel combustion) of 1963 in Australia?
Your answer should be very brief. 0. What is the ratio of the CO2 emissions (% of total fuel combustion) of 1960 in Middle income to that in North America?
Provide a succinct answer. 1.23. What is the ratio of the CO2 emissions (% of total fuel combustion) of 1961 in Middle income to that in North America?
Make the answer very short. 1.15. What is the ratio of the CO2 emissions (% of total fuel combustion) in 1962 in Middle income to that in North America?
Make the answer very short. 1.12. What is the ratio of the CO2 emissions (% of total fuel combustion) in 1963 in Middle income to that in North America?
Provide a succinct answer. 1.37. What is the ratio of the CO2 emissions (% of total fuel combustion) of 1960 in Middle income to that in OECD members?
Keep it short and to the point. 1.23. What is the ratio of the CO2 emissions (% of total fuel combustion) of 1961 in Middle income to that in OECD members?
Make the answer very short. 1.17. What is the ratio of the CO2 emissions (% of total fuel combustion) of 1962 in Middle income to that in OECD members?
Keep it short and to the point. 1.12. What is the ratio of the CO2 emissions (% of total fuel combustion) in 1963 in Middle income to that in OECD members?
Make the answer very short. 1.31. What is the ratio of the CO2 emissions (% of total fuel combustion) in 1961 in Middle income to that in Upper middle income?
Give a very brief answer. 1. What is the ratio of the CO2 emissions (% of total fuel combustion) of 1962 in Middle income to that in Upper middle income?
Offer a very short reply. 1. What is the ratio of the CO2 emissions (% of total fuel combustion) in 1963 in Middle income to that in Upper middle income?
Ensure brevity in your answer.  1. What is the ratio of the CO2 emissions (% of total fuel combustion) of 1960 in Middle income to that in World?
Your response must be concise. 1.23. What is the ratio of the CO2 emissions (% of total fuel combustion) of 1961 in Middle income to that in World?
Offer a terse response. 1.17. What is the ratio of the CO2 emissions (% of total fuel combustion) in 1962 in Middle income to that in World?
Your answer should be very brief. 1.12. What is the ratio of the CO2 emissions (% of total fuel combustion) of 1963 in Middle income to that in World?
Give a very brief answer. 1.31. What is the ratio of the CO2 emissions (% of total fuel combustion) in 1960 in Middle income to that in Australia?
Offer a very short reply. 14.48. What is the ratio of the CO2 emissions (% of total fuel combustion) of 1961 in Middle income to that in Australia?
Provide a succinct answer. 13.8. What is the ratio of the CO2 emissions (% of total fuel combustion) in 1962 in Middle income to that in Australia?
Offer a very short reply. 14.53. What is the ratio of the CO2 emissions (% of total fuel combustion) in 1963 in Middle income to that in Australia?
Offer a very short reply. 16.98. What is the ratio of the CO2 emissions (% of total fuel combustion) of 1961 in North America to that in OECD members?
Provide a succinct answer. 1.02. What is the ratio of the CO2 emissions (% of total fuel combustion) of 1962 in North America to that in OECD members?
Make the answer very short. 1. What is the ratio of the CO2 emissions (% of total fuel combustion) in 1963 in North America to that in OECD members?
Offer a terse response. 0.96. What is the ratio of the CO2 emissions (% of total fuel combustion) in 1960 in North America to that in Upper middle income?
Provide a short and direct response. 0.81. What is the ratio of the CO2 emissions (% of total fuel combustion) in 1961 in North America to that in Upper middle income?
Your answer should be compact. 0.87. What is the ratio of the CO2 emissions (% of total fuel combustion) in 1962 in North America to that in Upper middle income?
Offer a very short reply. 0.89. What is the ratio of the CO2 emissions (% of total fuel combustion) of 1963 in North America to that in Upper middle income?
Ensure brevity in your answer.  0.73. What is the ratio of the CO2 emissions (% of total fuel combustion) of 1961 in North America to that in World?
Your answer should be compact. 1.02. What is the ratio of the CO2 emissions (% of total fuel combustion) of 1962 in North America to that in World?
Your answer should be very brief. 1. What is the ratio of the CO2 emissions (% of total fuel combustion) in 1963 in North America to that in World?
Your response must be concise. 0.96. What is the ratio of the CO2 emissions (% of total fuel combustion) in 1960 in North America to that in Australia?
Offer a very short reply. 11.74. What is the ratio of the CO2 emissions (% of total fuel combustion) of 1961 in North America to that in Australia?
Provide a short and direct response. 11.95. What is the ratio of the CO2 emissions (% of total fuel combustion) of 1962 in North America to that in Australia?
Offer a very short reply. 12.94. What is the ratio of the CO2 emissions (% of total fuel combustion) in 1963 in North America to that in Australia?
Offer a very short reply. 12.41. What is the ratio of the CO2 emissions (% of total fuel combustion) of 1960 in OECD members to that in Upper middle income?
Your answer should be compact. 0.81. What is the ratio of the CO2 emissions (% of total fuel combustion) of 1961 in OECD members to that in Upper middle income?
Ensure brevity in your answer.  0.85. What is the ratio of the CO2 emissions (% of total fuel combustion) of 1962 in OECD members to that in Upper middle income?
Your answer should be very brief. 0.89. What is the ratio of the CO2 emissions (% of total fuel combustion) in 1963 in OECD members to that in Upper middle income?
Provide a succinct answer. 0.76. What is the ratio of the CO2 emissions (% of total fuel combustion) in 1960 in OECD members to that in World?
Provide a succinct answer. 1. What is the ratio of the CO2 emissions (% of total fuel combustion) in 1961 in OECD members to that in World?
Make the answer very short. 1. What is the ratio of the CO2 emissions (% of total fuel combustion) of 1962 in OECD members to that in World?
Offer a terse response. 1. What is the ratio of the CO2 emissions (% of total fuel combustion) in 1963 in OECD members to that in World?
Keep it short and to the point. 1. What is the ratio of the CO2 emissions (% of total fuel combustion) of 1960 in OECD members to that in Australia?
Your response must be concise. 11.75. What is the ratio of the CO2 emissions (% of total fuel combustion) in 1961 in OECD members to that in Australia?
Keep it short and to the point. 11.75. What is the ratio of the CO2 emissions (% of total fuel combustion) in 1962 in OECD members to that in Australia?
Provide a succinct answer. 12.96. What is the ratio of the CO2 emissions (% of total fuel combustion) in 1963 in OECD members to that in Australia?
Provide a short and direct response. 12.92. What is the ratio of the CO2 emissions (% of total fuel combustion) of 1960 in Upper middle income to that in World?
Make the answer very short. 1.23. What is the ratio of the CO2 emissions (% of total fuel combustion) of 1961 in Upper middle income to that in World?
Ensure brevity in your answer.  1.17. What is the ratio of the CO2 emissions (% of total fuel combustion) of 1962 in Upper middle income to that in World?
Your answer should be very brief. 1.12. What is the ratio of the CO2 emissions (% of total fuel combustion) of 1963 in Upper middle income to that in World?
Ensure brevity in your answer.  1.31. What is the ratio of the CO2 emissions (% of total fuel combustion) in 1960 in Upper middle income to that in Australia?
Give a very brief answer. 14.48. What is the ratio of the CO2 emissions (% of total fuel combustion) in 1961 in Upper middle income to that in Australia?
Ensure brevity in your answer.  13.8. What is the ratio of the CO2 emissions (% of total fuel combustion) in 1962 in Upper middle income to that in Australia?
Provide a short and direct response. 14.53. What is the ratio of the CO2 emissions (% of total fuel combustion) in 1963 in Upper middle income to that in Australia?
Offer a very short reply. 16.98. What is the ratio of the CO2 emissions (% of total fuel combustion) of 1960 in World to that in Australia?
Make the answer very short. 11.75. What is the ratio of the CO2 emissions (% of total fuel combustion) in 1961 in World to that in Australia?
Provide a short and direct response. 11.75. What is the ratio of the CO2 emissions (% of total fuel combustion) in 1962 in World to that in Australia?
Make the answer very short. 12.96. What is the ratio of the CO2 emissions (% of total fuel combustion) in 1963 in World to that in Australia?
Keep it short and to the point. 12.92. What is the difference between the highest and the lowest CO2 emissions (% of total fuel combustion) in 1960?
Offer a very short reply. 23.25. What is the difference between the highest and the lowest CO2 emissions (% of total fuel combustion) in 1961?
Offer a very short reply. 21.95. What is the difference between the highest and the lowest CO2 emissions (% of total fuel combustion) of 1962?
Make the answer very short. 21.58. What is the difference between the highest and the lowest CO2 emissions (% of total fuel combustion) of 1963?
Your answer should be very brief. 25.42. 